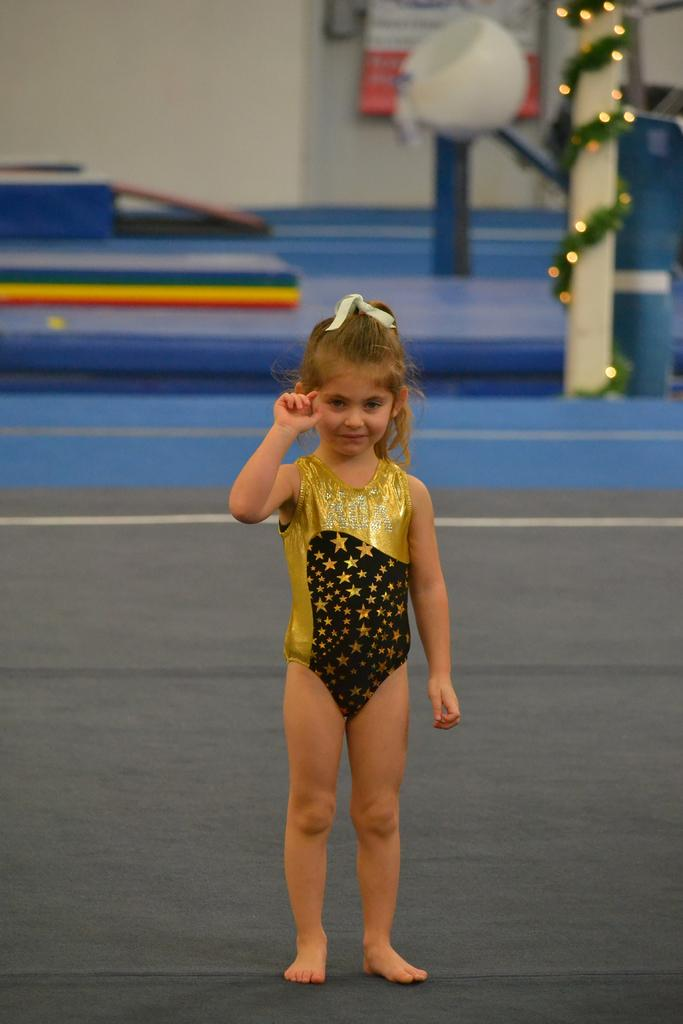Who is the main subject in the image? There is a girl in the image. What is the girl wearing? The girl is wearing a golden color dress. What is at the bottom of the image? There is a floor at the bottom of the image. What can be seen in the background of the image? There is a pole and a wall in the background of the image. How many jewels is the girl wearing in the image? There is no mention of jewels in the image. --- Facts: 1. There is a car in the image. 2. The car is red. 3. There are people standing near the car. 4. The car has four wheels. 5. The car has a license plate. Absurd Topics: dinosaur, ocean, Conversation: What is the main subject in the image? There is a car in the image. What color is the car? The car is red. Are there any people near the car? Yes, there are people standing near the car. How many wheels does the car have? The car has four wheels. Is there any information about the car's license plate? Yes, the car has a license plate. Reasoning: Let's think step by step in order to produce the conversation. We start by identifying the main subject of the image, which is the car. Next, we describe specific features of the car, such as its color (red) and the number of wheels it has (four wheels)). Then, we observe the actions of the people in the image, noting that they are standing near the car. Finally, we describe any additional information about the car, such as the presence of a license plate. Absurd Question/Answer: Can you see a dinosaur in the image? No, there is no dinosaur present in the image. --- Facts: 1. There is a cat in the image. 2. The cat is black and white. 3. The cat is sitting on a chair. 4. There is a bowl of milk next to the chair. 5. The background of the image is a living room. Absurd Topics: elephant, jungle, kangaroo, Conversation: What type of animal is in the image? There is a cat in the image. What is the color pattern of the cat? The cat is black and white. What is the cat doing in the image? The cat is sitting on a chair. What is next to the chair in the image? There is a bowl of milk next to the chair. What is the setting of the image? The background of the image is a living room. Reasoning: Let's think step by step in order to produce the conversation. We start by identifying the main subject of the image, which is the cat. Next, we describe 